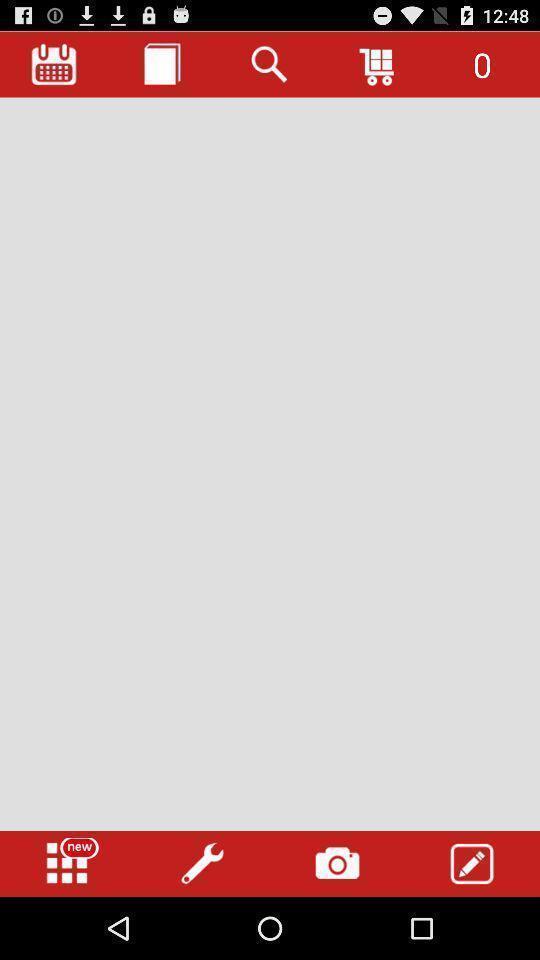Describe the content in this image. Screen page displaying different options. 